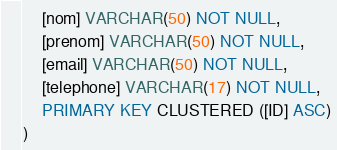Convert code to text. <code><loc_0><loc_0><loc_500><loc_500><_SQL_>    [nom] VARCHAR(50) NOT NULL, 
    [prenom] VARCHAR(50) NOT NULL, 
    [email] VARCHAR(50) NOT NULL, 
    [telephone] VARCHAR(17) NOT NULL,
	PRIMARY KEY CLUSTERED ([ID] ASC)
)</code> 